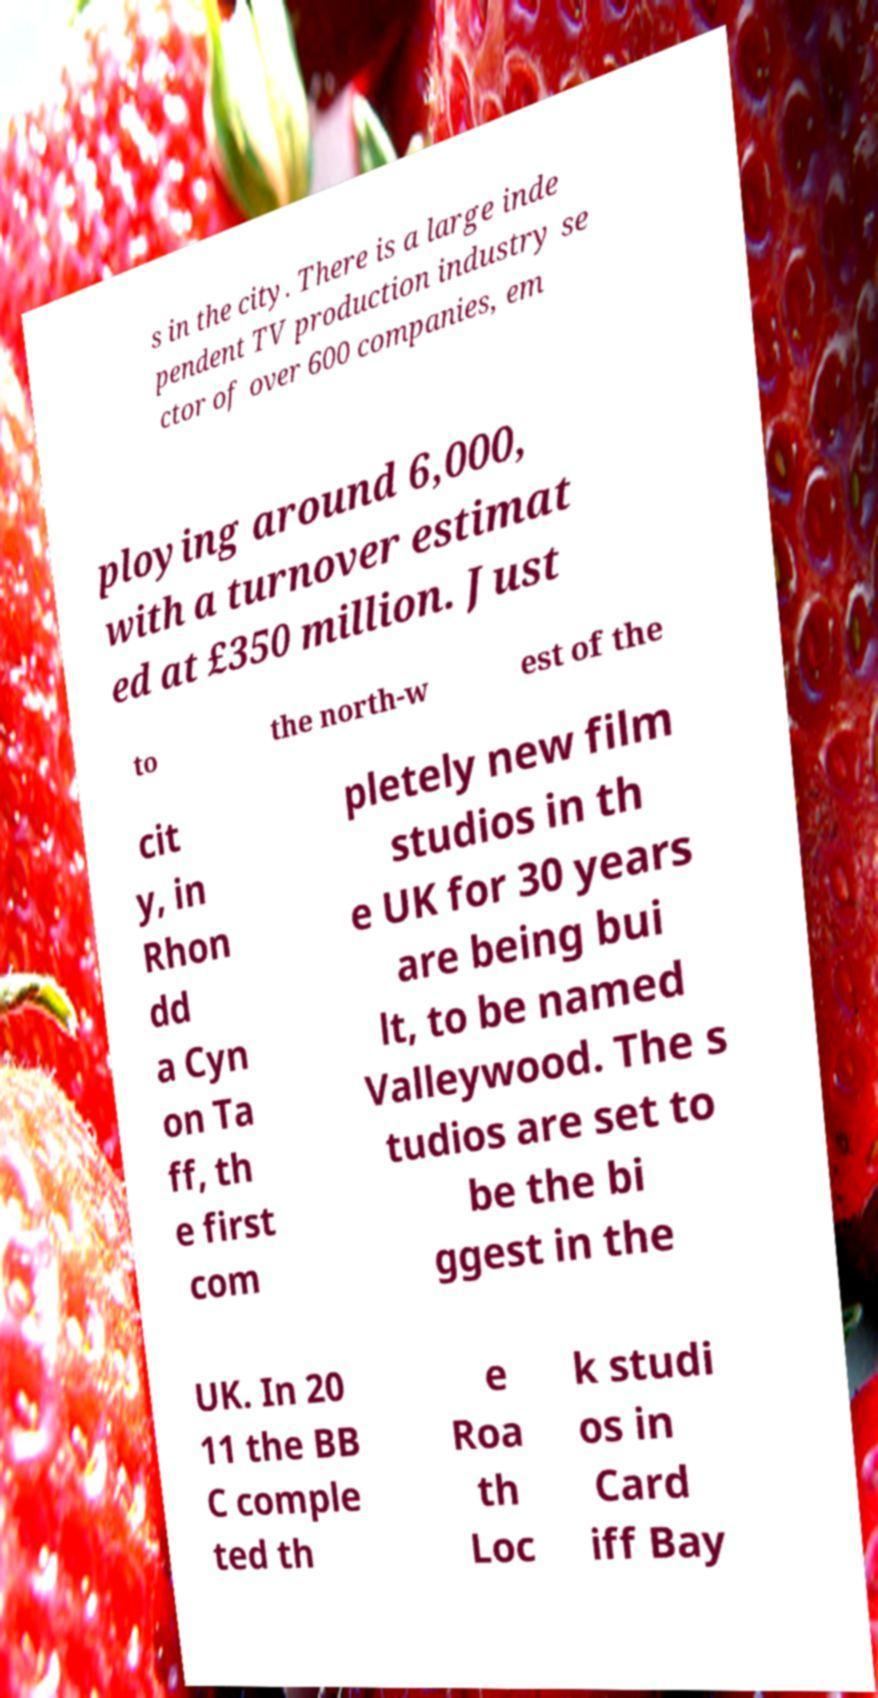There's text embedded in this image that I need extracted. Can you transcribe it verbatim? s in the city. There is a large inde pendent TV production industry se ctor of over 600 companies, em ploying around 6,000, with a turnover estimat ed at £350 million. Just to the north-w est of the cit y, in Rhon dd a Cyn on Ta ff, th e first com pletely new film studios in th e UK for 30 years are being bui lt, to be named Valleywood. The s tudios are set to be the bi ggest in the UK. In 20 11 the BB C comple ted th e Roa th Loc k studi os in Card iff Bay 